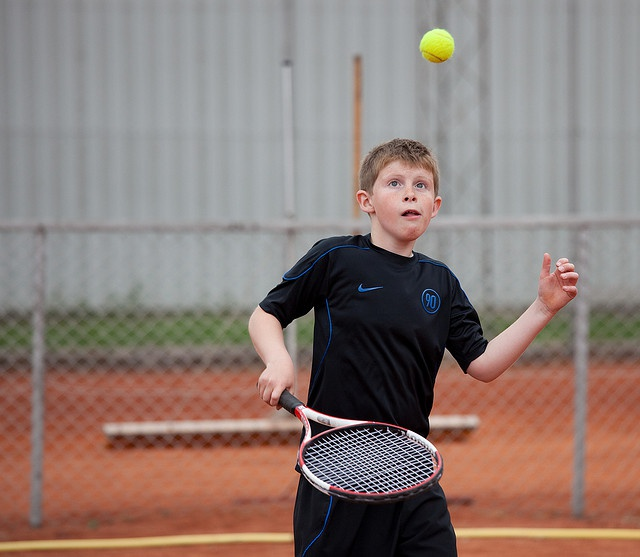Describe the objects in this image and their specific colors. I can see people in gray, black, lightpink, darkgray, and brown tones, tennis racket in gray, black, lavender, and darkgray tones, and sports ball in gray, khaki, yellow, and olive tones in this image. 